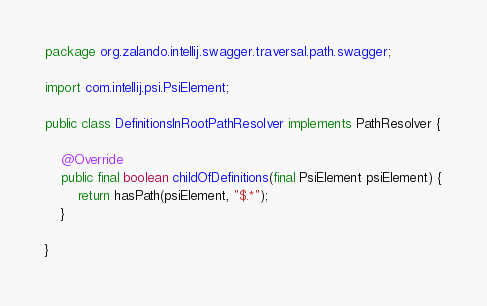<code> <loc_0><loc_0><loc_500><loc_500><_Java_>package org.zalando.intellij.swagger.traversal.path.swagger;

import com.intellij.psi.PsiElement;

public class DefinitionsInRootPathResolver implements PathResolver {

    @Override
    public final boolean childOfDefinitions(final PsiElement psiElement) {
        return hasPath(psiElement, "$.*");
    }

}
</code> 